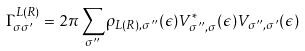Convert formula to latex. <formula><loc_0><loc_0><loc_500><loc_500>\Gamma _ { \sigma \sigma ^ { \prime } } ^ { L ( R ) } = 2 \pi \sum _ { \sigma ^ { \prime \prime } } \rho _ { L ( R ) , \sigma ^ { \prime \prime } } ( \epsilon ) V _ { \sigma ^ { \prime \prime } , \sigma } ^ { * } ( \epsilon ) V _ { \sigma ^ { \prime \prime } , \sigma ^ { \prime } } ( \epsilon )</formula> 